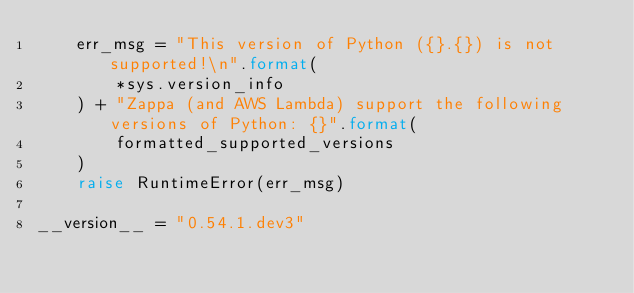<code> <loc_0><loc_0><loc_500><loc_500><_Python_>    err_msg = "This version of Python ({}.{}) is not supported!\n".format(
        *sys.version_info
    ) + "Zappa (and AWS Lambda) support the following versions of Python: {}".format(
        formatted_supported_versions
    )
    raise RuntimeError(err_msg)

__version__ = "0.54.1.dev3"
</code> 